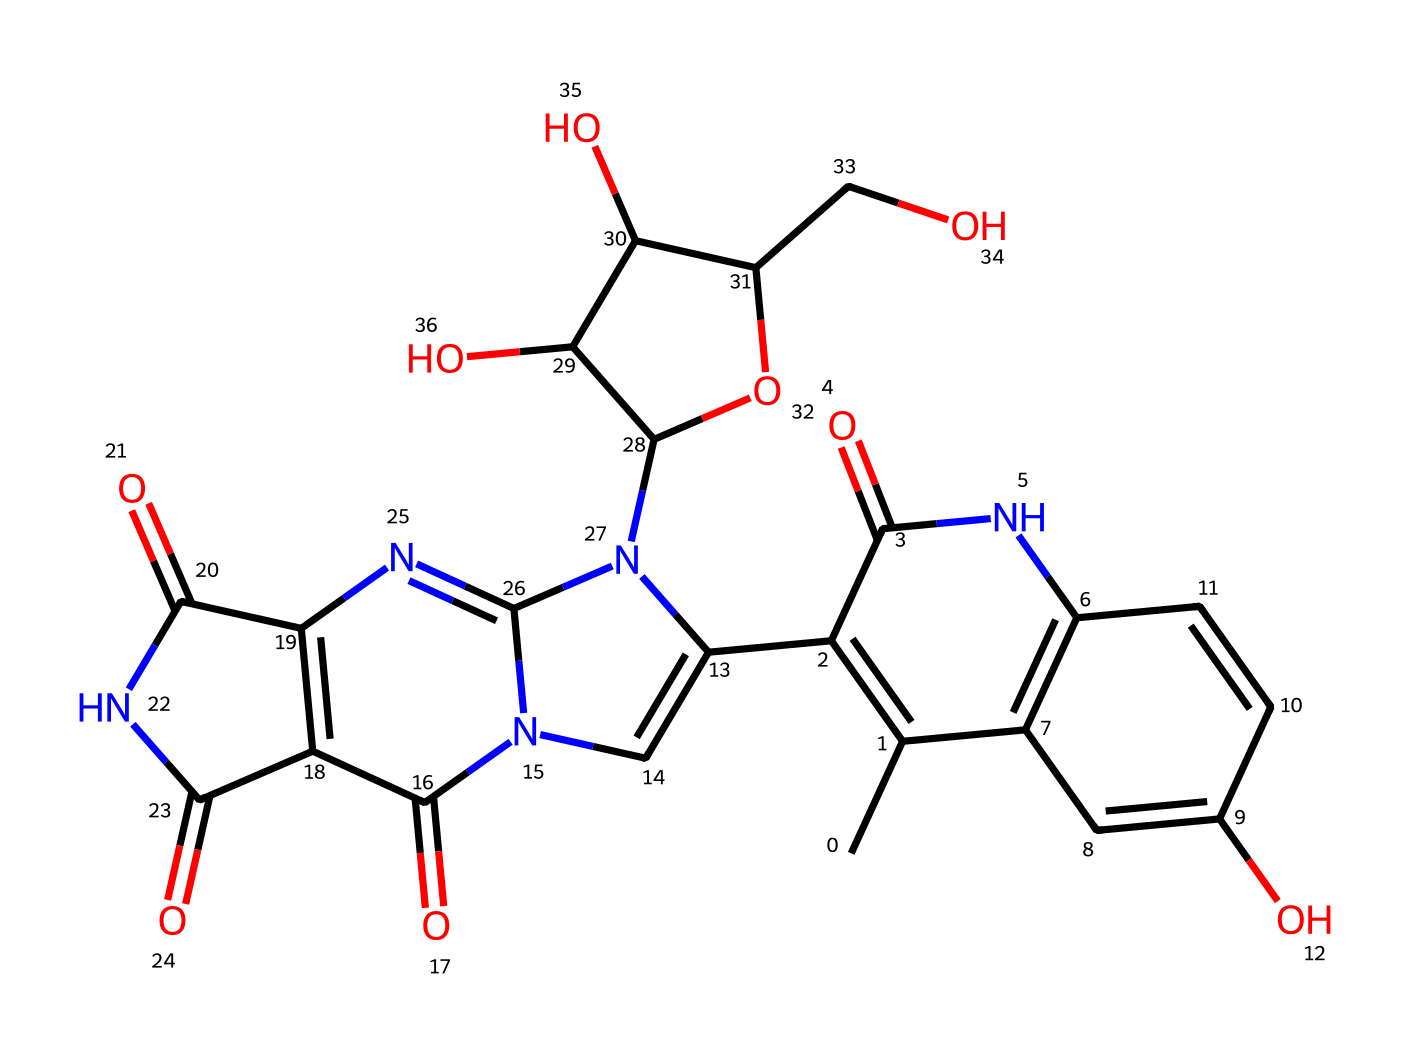What is the molecular formula of this chemical? By analyzing the SMILES representation, we can count the number of each type of atom present in the structure. In the provided SMILES, we identify carbon (C), hydrogen (H), nitrogen (N), and oxygen (O) atoms. Counting gives us: 21 carbons, 22 hydrogens, 4 nitrogens, and 6 oxygens. Thus, the molecular formula can be summarized as C21H22N4O6.
Answer: C21H22N4O6 How many rings are present in this chemical structure? In the SMILES representation, we can identify the parts of the molecule that are enclosed by numbers. The numbers indicate the start and end of a ring. By following the SMILES, we find multiple instances of rings formed between carbon atoms. Specifically, there are 5 distinct ring closures found in the structure.
Answer: 5 What type of bonding is primarily present in this molecule? Examining the connectivity between the atoms in the SMILES, we see that this structure contains both single and double bonds. The presence of multiple double bonds between carbons and also between nitrogen and carbon suggests that there are some unsaturated points in the molecule. Given the combination, the primary type of bonding is indeed covalent bonding.
Answer: covalent Which atom types can be found in the structure? Parsing through the SMILES string, we can identify the types of atoms based on their symbols. This molecule contains carbon (C), hydrogen (H), nitrogen (N), and oxygen (O). These are the species that are present and form the backbone of the chemical structure.
Answer: carbon, hydrogen, nitrogen, oxygen Are there any functional groups in this chemical? Looking closely at the SMILES, we can note that certain segments are indicative of functional groups. For instance, the presence of carbonyl groups (C=O) and amine groups (N) suggest the molecule has functionalities commonly associated with amides or aromatic compounds. The presence of hydroxyl (–OH) indicates alcohol or phenolic groups. Thus, several functional groups exist.
Answer: amide, carbonyl, hydroxyl 